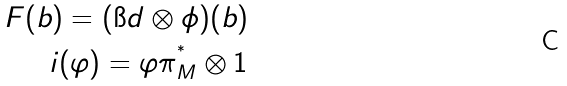<formula> <loc_0><loc_0><loc_500><loc_500>F ( b ) = ( \i d \otimes \phi ) ( b ) \\ i ( \varphi ) = \varphi \pi ^ { ^ { * } } _ { M } \otimes 1</formula> 